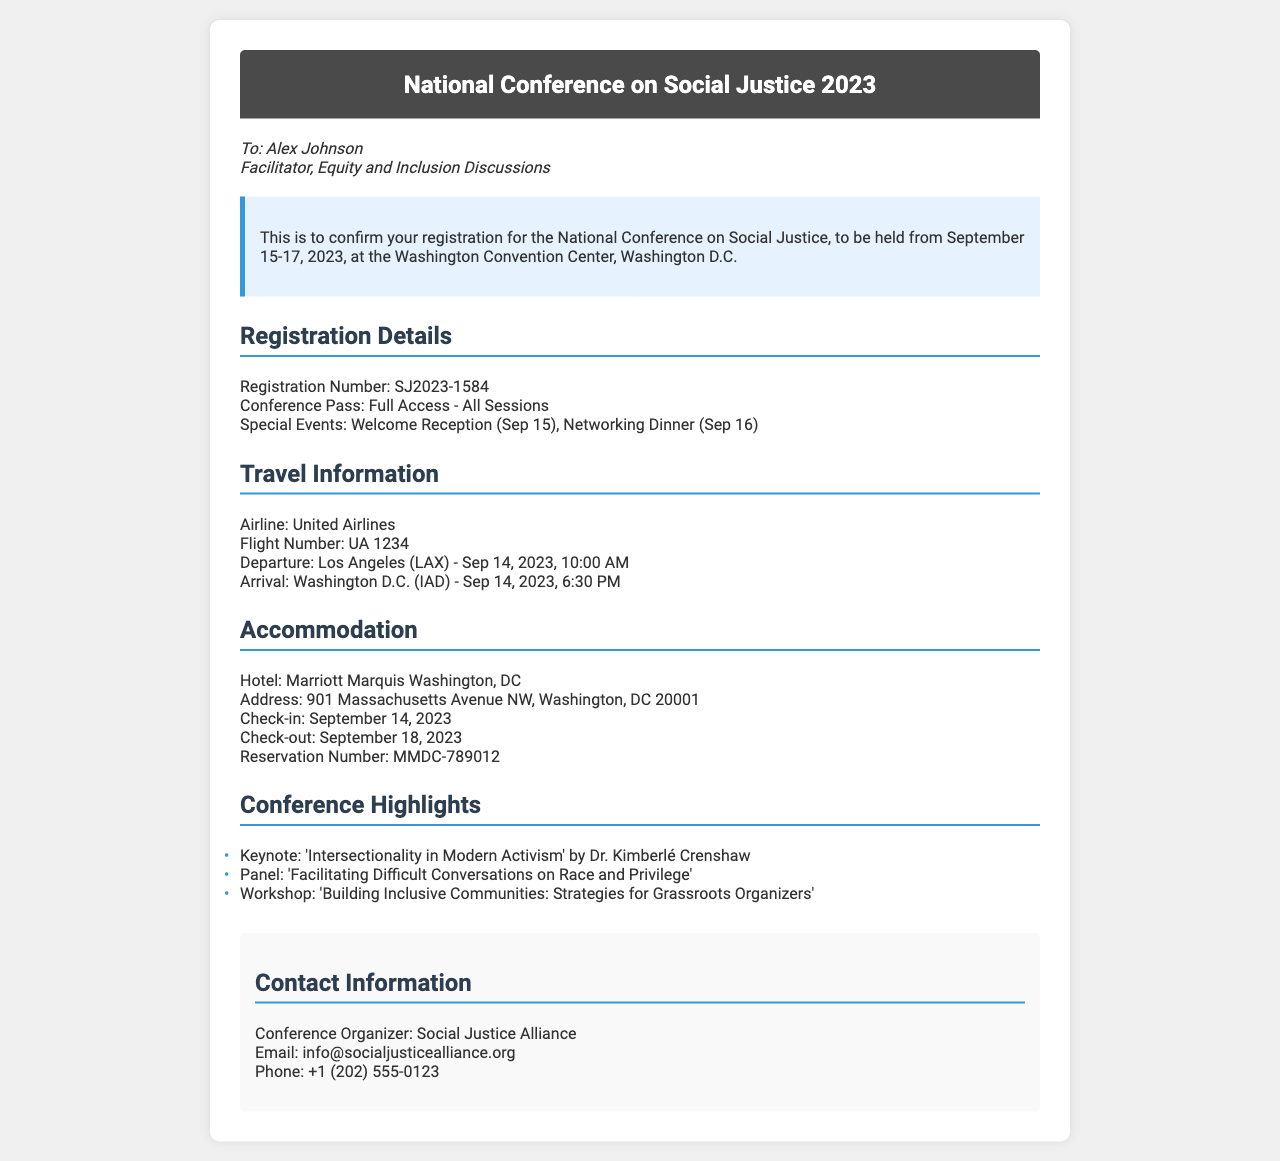What are the conference dates? The conference dates are specified in the document as September 15-17, 2023.
Answer: September 15-17, 2023 What is the registration number? The registration number is listed in the document under Registration Details.
Answer: SJ2023-1584 Who is the keynote speaker? The keynote speaker is mentioned under Conference Highlights.
Answer: Dr. Kimberlé Crenshaw What is the hotel name? The hotel name is found under the Accommodation section.
Answer: Marriott Marquis Washington, DC What is the check-in date? The check-in date is included in the Accommodation details.
Answer: September 14, 2023 What special event takes place on September 15? The special event is mentioned within the Registration Details section.
Answer: Welcome Reception What flight leaves from Los Angeles? The specific flight information is provided in the Travel Information section.
Answer: UA 1234 What is the contact email for the conference organizer? The contact email is listed under the Contact Information section of the document.
Answer: info@socialjusticealliance.org 